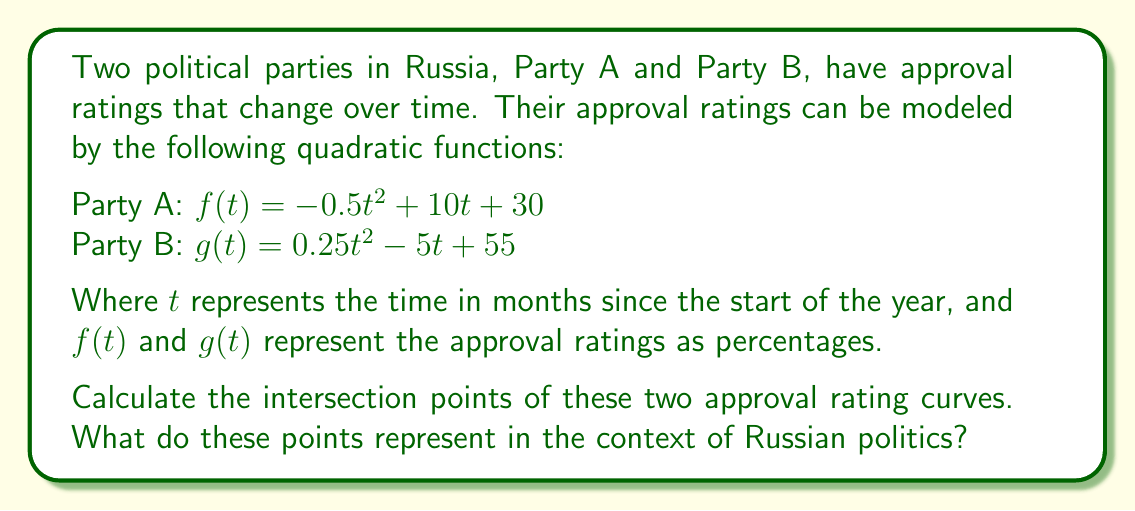Can you solve this math problem? To find the intersection points, we need to solve the equation $f(t) = g(t)$:

1) Set up the equation:
   $-0.5t^2 + 10t + 30 = 0.25t^2 - 5t + 55$

2) Rearrange terms to standard form:
   $-0.75t^2 + 15t - 25 = 0$

3) Multiply all terms by -4/3 to simplify coefficients:
   $t^2 - 20t + \frac{100}{3} = 0$

4) Use the quadratic formula: $t = \frac{-b \pm \sqrt{b^2 - 4ac}}{2a}$
   Where $a = 1$, $b = -20$, and $c = \frac{100}{3}$

5) Substitute into the formula:
   $t = \frac{20 \pm \sqrt{400 - \frac{400}{3}}}{2} = \frac{20 \pm \sqrt{\frac{800}{3}}}{2}$

6) Simplify:
   $t = 10 \pm \frac{\sqrt{800/3}}{2} = 10 \pm \frac{2\sqrt{200/3}}{2} = 10 \pm \frac{2\sqrt{66.67}}{2}$

7) Calculate the final values:
   $t_1 \approx 2.35$ and $t_2 \approx 17.65$

These intersection points represent the times (in months) when the approval ratings of both parties are equal. In the context of Russian politics, they indicate the moments when public support shifts from one party to the other.
Answer: $t_1 \approx 2.35$ months, $t_2 \approx 17.65$ months 